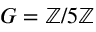<formula> <loc_0><loc_0><loc_500><loc_500>G = \mathbb { Z } / 5 \mathbb { Z }</formula> 